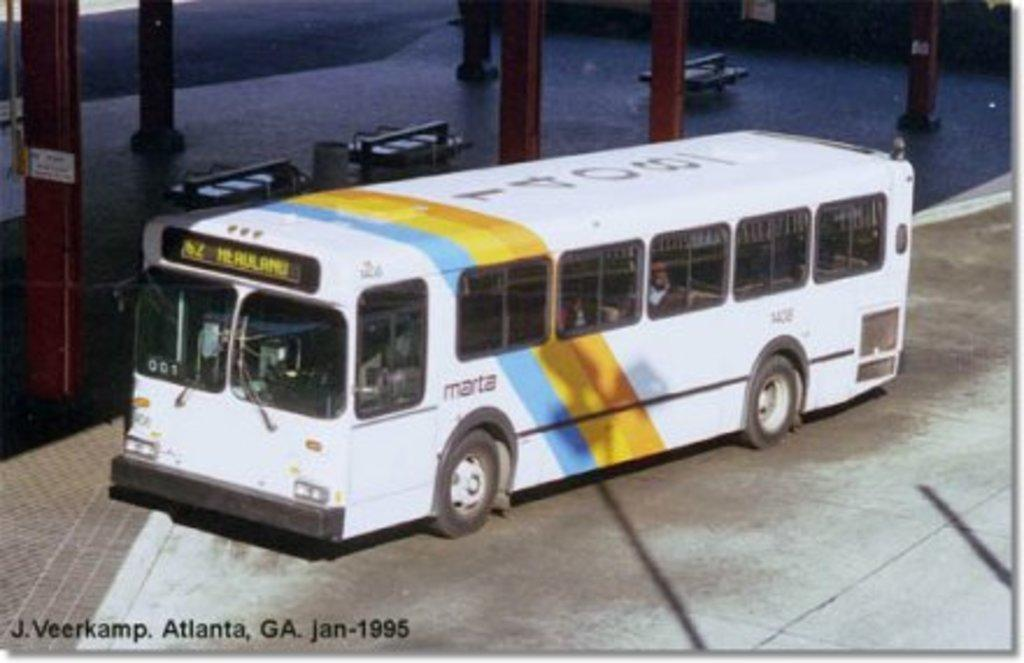<image>
Describe the image concisely. A Marta city bus in Atlanta, Georgia in 1995. 